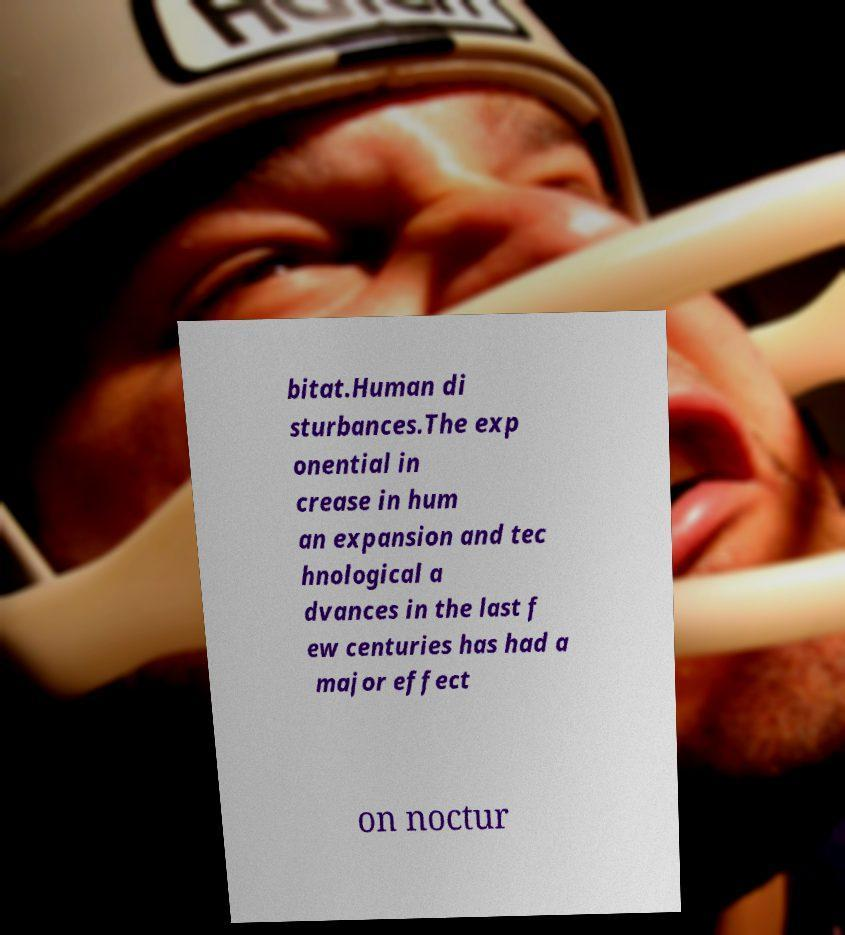Could you assist in decoding the text presented in this image and type it out clearly? bitat.Human di sturbances.The exp onential in crease in hum an expansion and tec hnological a dvances in the last f ew centuries has had a major effect on noctur 